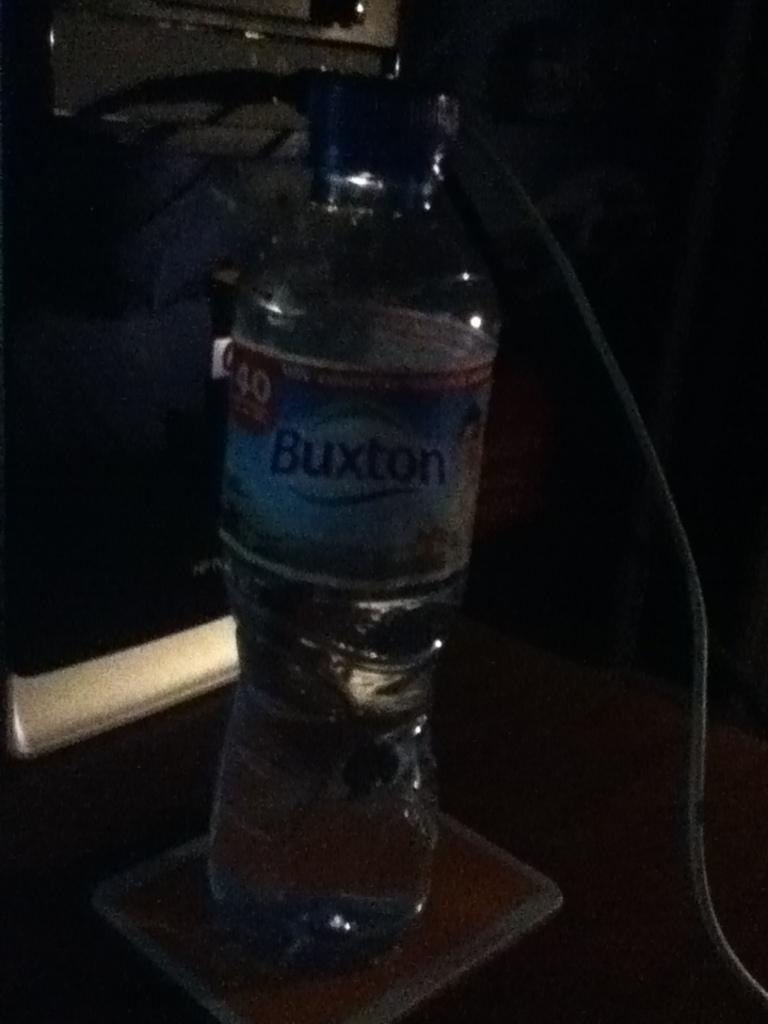<image>
Provide a brief description of the given image. a Buxton branded bottle of water sitting on a table. 